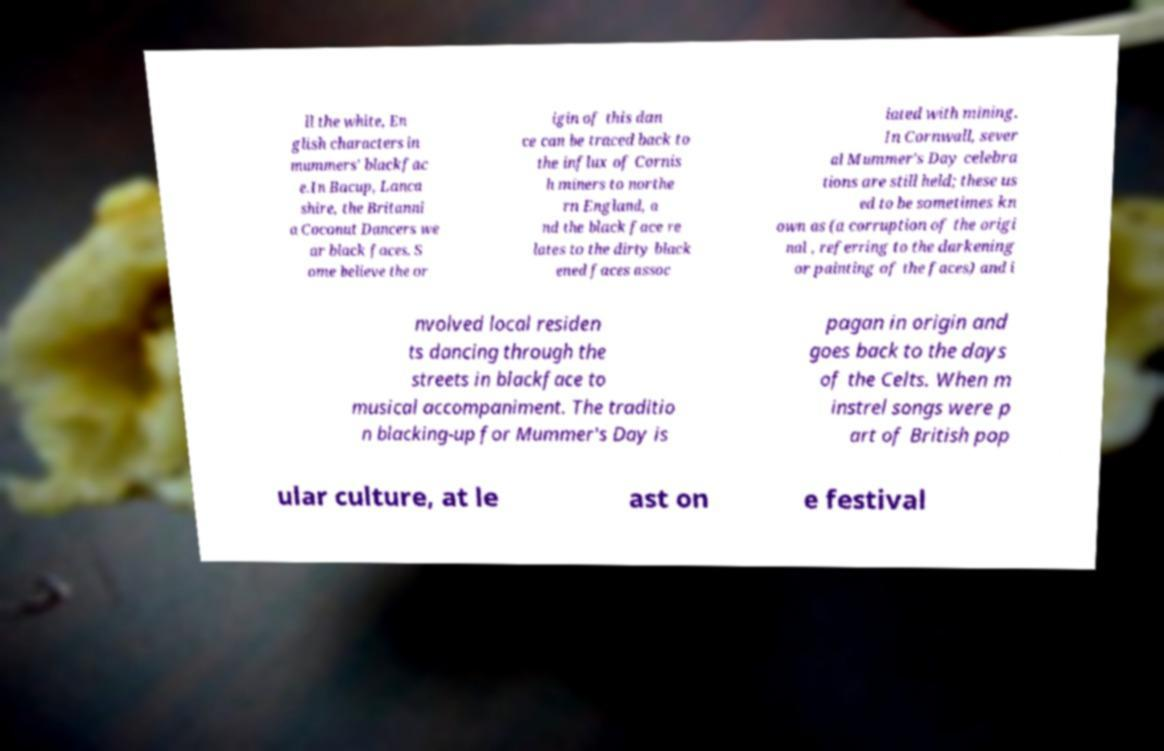Please identify and transcribe the text found in this image. ll the white, En glish characters in mummers' blackfac e.In Bacup, Lanca shire, the Britanni a Coconut Dancers we ar black faces. S ome believe the or igin of this dan ce can be traced back to the influx of Cornis h miners to northe rn England, a nd the black face re lates to the dirty black ened faces assoc iated with mining. In Cornwall, sever al Mummer's Day celebra tions are still held; these us ed to be sometimes kn own as (a corruption of the origi nal , referring to the darkening or painting of the faces) and i nvolved local residen ts dancing through the streets in blackface to musical accompaniment. The traditio n blacking-up for Mummer's Day is pagan in origin and goes back to the days of the Celts. When m instrel songs were p art of British pop ular culture, at le ast on e festival 